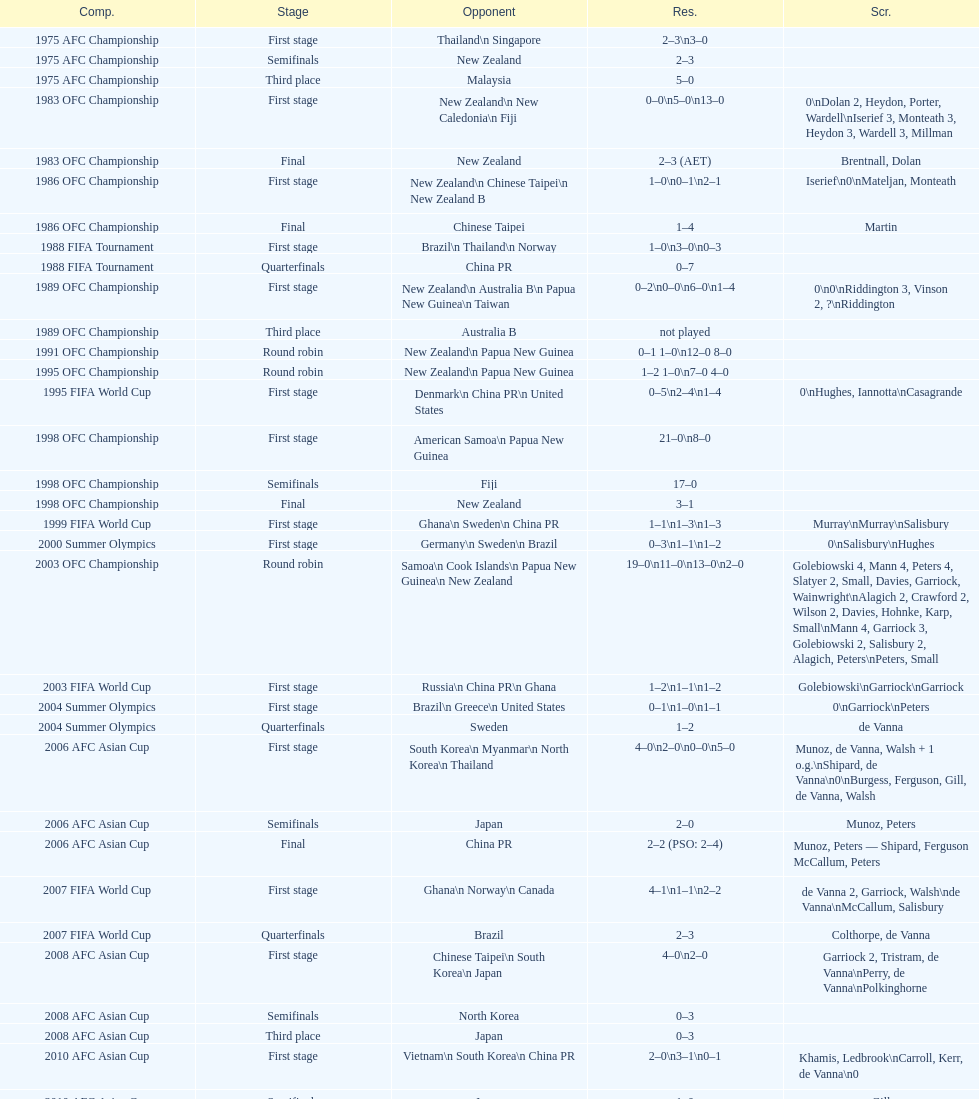How many players scored during the 1983 ofc championship competition? 9. 